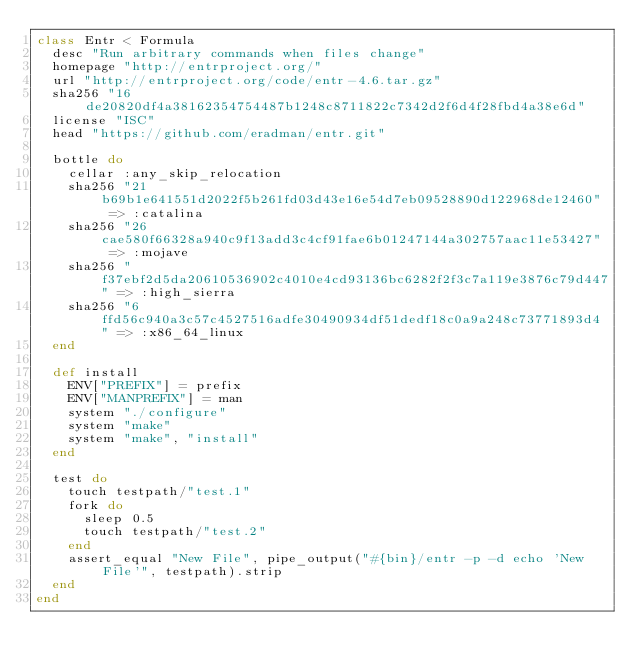<code> <loc_0><loc_0><loc_500><loc_500><_Ruby_>class Entr < Formula
  desc "Run arbitrary commands when files change"
  homepage "http://entrproject.org/"
  url "http://entrproject.org/code/entr-4.6.tar.gz"
  sha256 "16de20820df4a38162354754487b1248c8711822c7342d2f6d4f28fbd4a38e6d"
  license "ISC"
  head "https://github.com/eradman/entr.git"

  bottle do
    cellar :any_skip_relocation
    sha256 "21b69b1e641551d2022f5b261fd03d43e16e54d7eb09528890d122968de12460" => :catalina
    sha256 "26cae580f66328a940c9f13add3c4cf91fae6b01247144a302757aac11e53427" => :mojave
    sha256 "f37ebf2d5da20610536902c4010e4cd93136bc6282f2f3c7a119e3876c79d447" => :high_sierra
    sha256 "6ffd56c940a3c57c4527516adfe30490934df51dedf18c0a9a248c73771893d4" => :x86_64_linux
  end

  def install
    ENV["PREFIX"] = prefix
    ENV["MANPREFIX"] = man
    system "./configure"
    system "make"
    system "make", "install"
  end

  test do
    touch testpath/"test.1"
    fork do
      sleep 0.5
      touch testpath/"test.2"
    end
    assert_equal "New File", pipe_output("#{bin}/entr -p -d echo 'New File'", testpath).strip
  end
end
</code> 